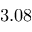<formula> <loc_0><loc_0><loc_500><loc_500>3 . 0 8</formula> 